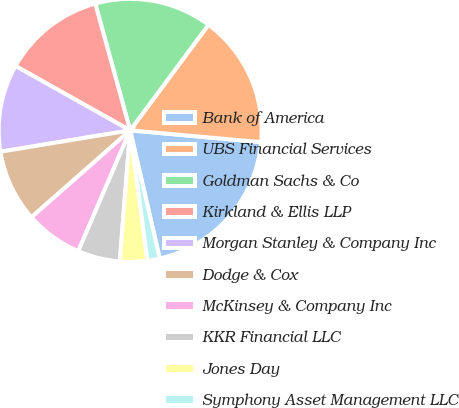<chart> <loc_0><loc_0><loc_500><loc_500><pie_chart><fcel>Bank of America<fcel>UBS Financial Services<fcel>Goldman Sachs & Co<fcel>Kirkland & Ellis LLP<fcel>Morgan Stanley & Company Inc<fcel>Dodge & Cox<fcel>McKinsey & Company Inc<fcel>KKR Financial LLC<fcel>Jones Day<fcel>Symphony Asset Management LLC<nl><fcel>19.96%<fcel>16.27%<fcel>14.43%<fcel>12.58%<fcel>10.74%<fcel>8.89%<fcel>7.05%<fcel>5.2%<fcel>3.36%<fcel>1.51%<nl></chart> 